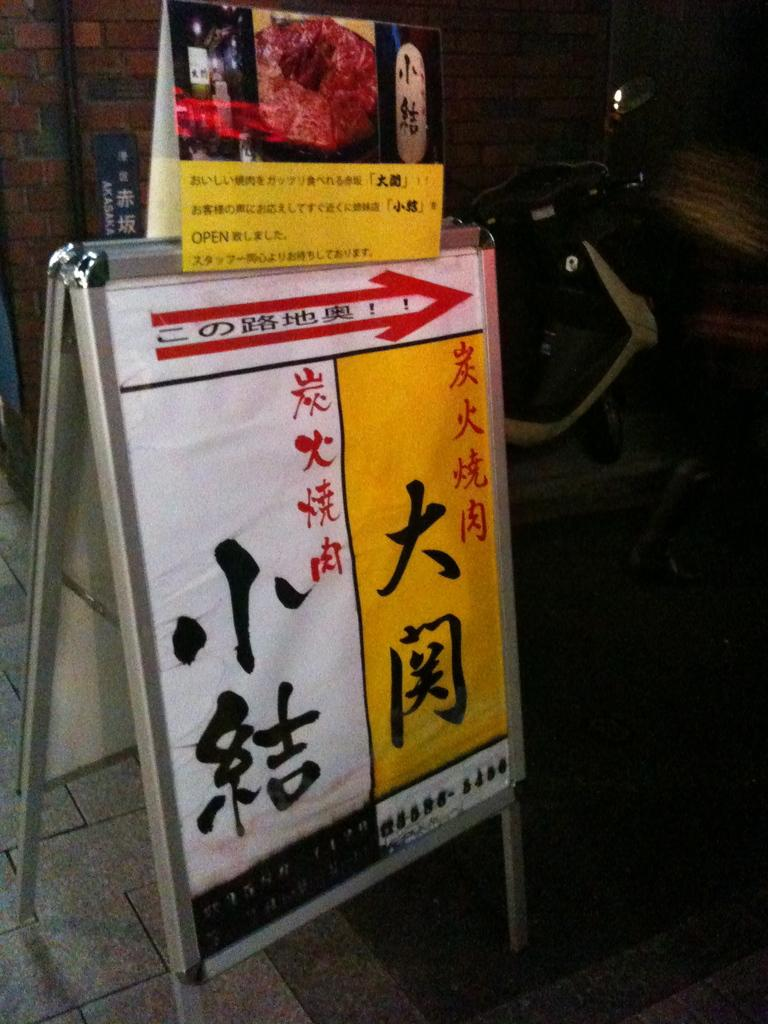What is hanging or displayed in the image? There is a banner in the image. What object can be seen on the ground in the image? There is a bike parked on the ground in the image. Where is the sofa located in the image? There is no sofa present in the image. What type of bait is being used by the person in the image? There is no person or bait present in the image. 